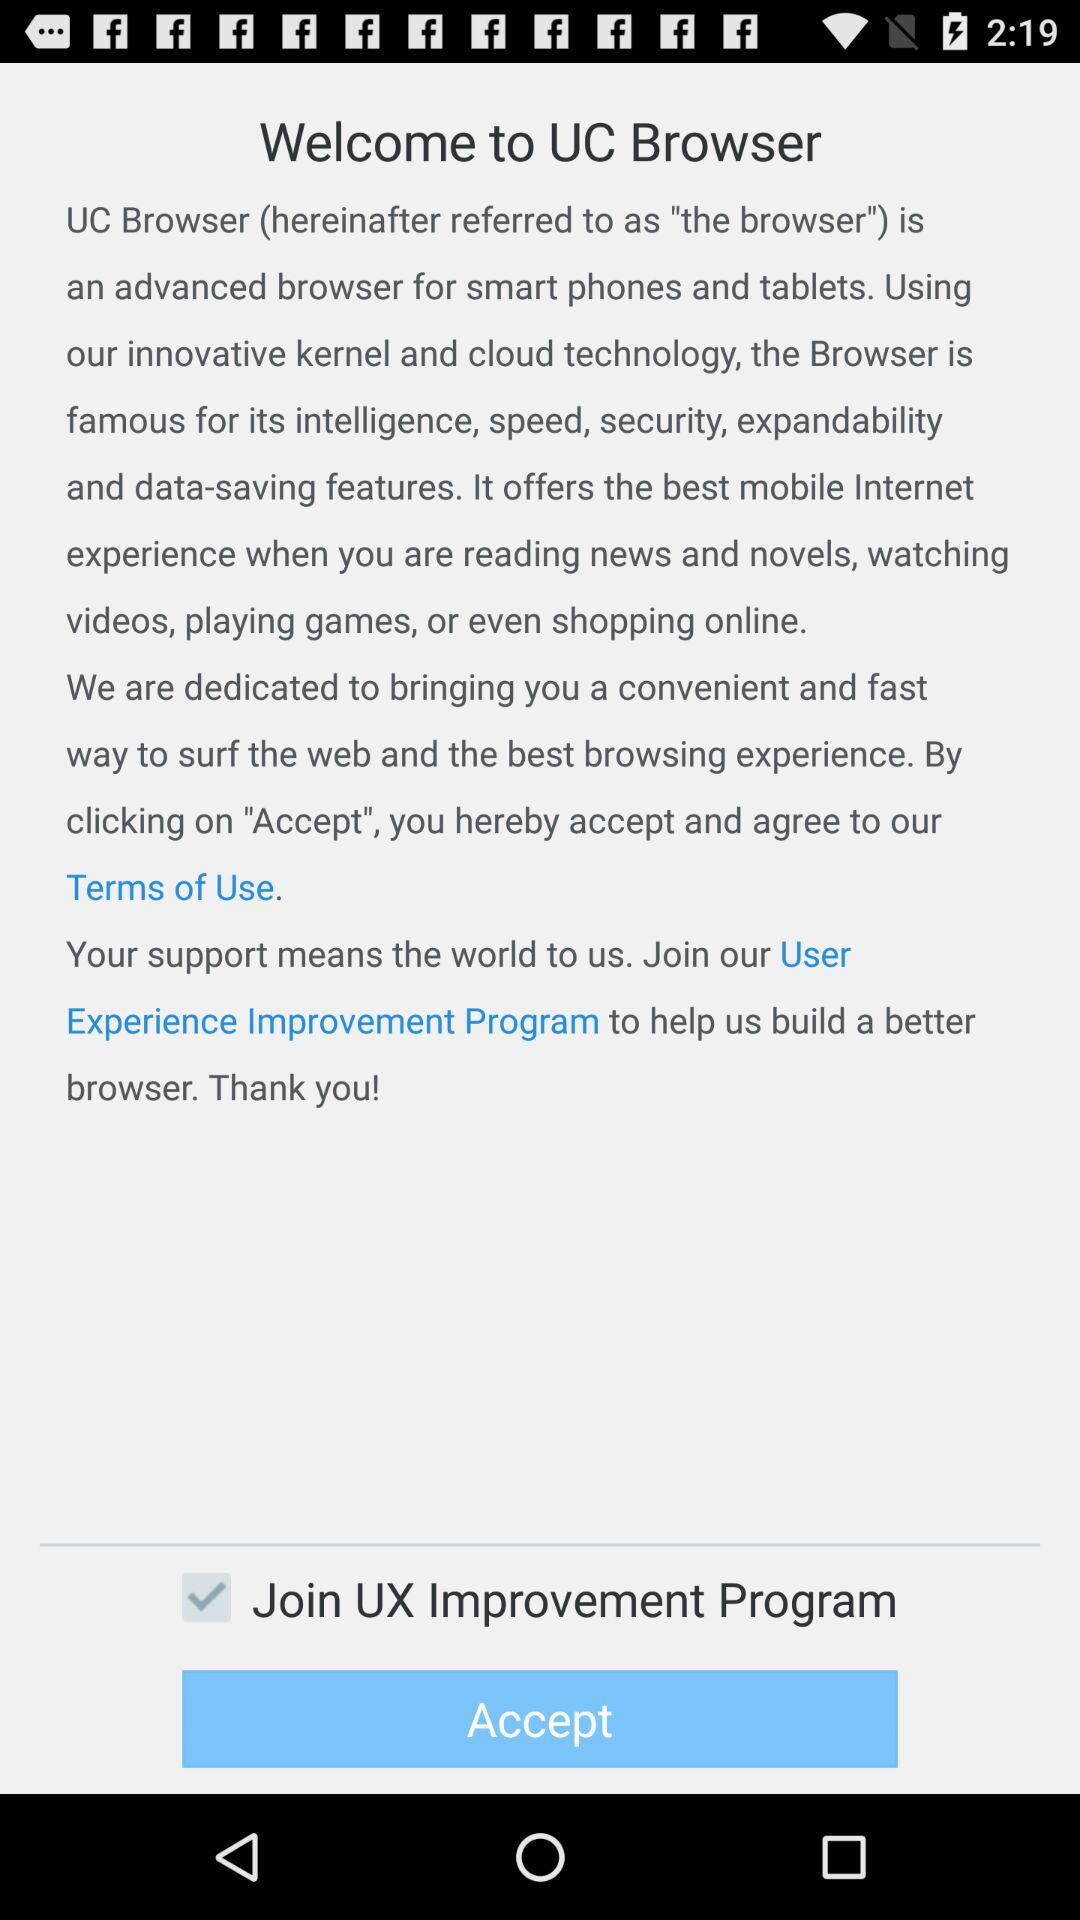What is the "UC Browser"? The "UC Browser" is an advanced browser for smart phones and tablets. 